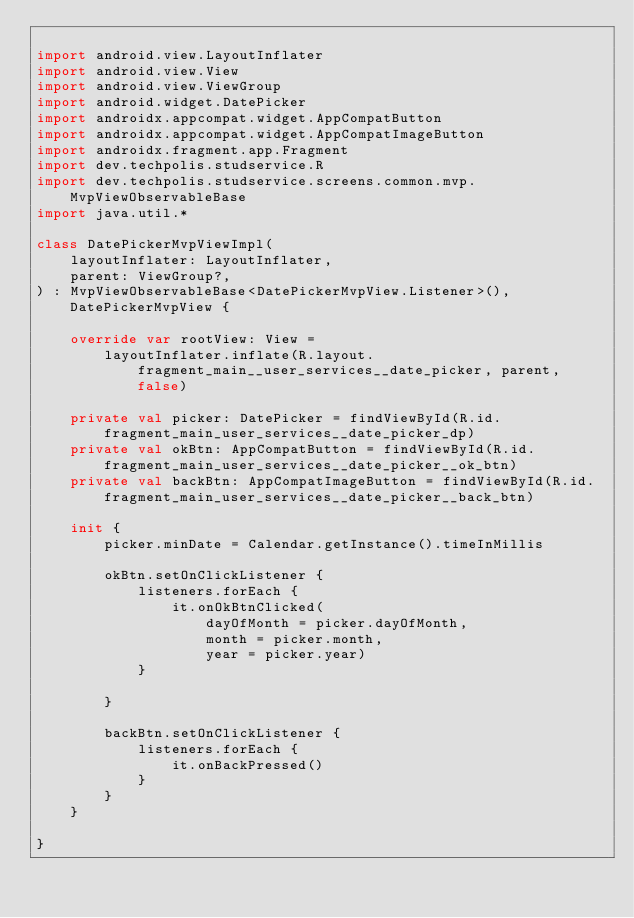<code> <loc_0><loc_0><loc_500><loc_500><_Kotlin_>
import android.view.LayoutInflater
import android.view.View
import android.view.ViewGroup
import android.widget.DatePicker
import androidx.appcompat.widget.AppCompatButton
import androidx.appcompat.widget.AppCompatImageButton
import androidx.fragment.app.Fragment
import dev.techpolis.studservice.R
import dev.techpolis.studservice.screens.common.mvp.MvpViewObservableBase
import java.util.*

class DatePickerMvpViewImpl(
    layoutInflater: LayoutInflater,
    parent: ViewGroup?,
) : MvpViewObservableBase<DatePickerMvpView.Listener>(), DatePickerMvpView {

    override var rootView: View =
        layoutInflater.inflate(R.layout.fragment_main__user_services__date_picker, parent, false)

    private val picker: DatePicker = findViewById(R.id.fragment_main_user_services__date_picker_dp)
    private val okBtn: AppCompatButton = findViewById(R.id.fragment_main_user_services__date_picker__ok_btn)
    private val backBtn: AppCompatImageButton = findViewById(R.id.fragment_main_user_services__date_picker__back_btn)

    init {
        picker.minDate = Calendar.getInstance().timeInMillis

        okBtn.setOnClickListener {
            listeners.forEach {
                it.onOkBtnClicked(
                    dayOfMonth = picker.dayOfMonth,
                    month = picker.month,
                    year = picker.year)
            }

        }

        backBtn.setOnClickListener {
            listeners.forEach {
                it.onBackPressed()
            }
        }
    }

}</code> 